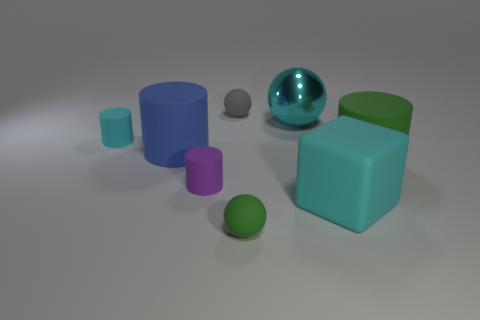Add 1 small objects. How many objects exist? 9 Subtract all cubes. How many objects are left? 7 Subtract 1 blue cylinders. How many objects are left? 7 Subtract all big purple matte balls. Subtract all tiny spheres. How many objects are left? 6 Add 8 cyan cylinders. How many cyan cylinders are left? 9 Add 6 cyan metallic things. How many cyan metallic things exist? 7 